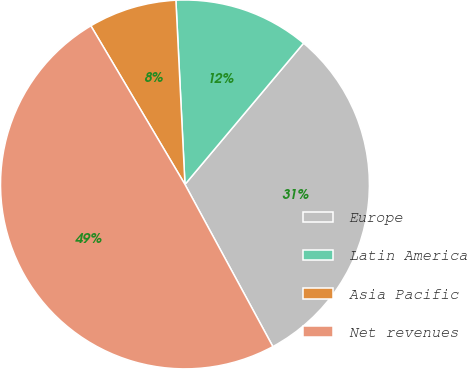Convert chart. <chart><loc_0><loc_0><loc_500><loc_500><pie_chart><fcel>Europe<fcel>Latin America<fcel>Asia Pacific<fcel>Net revenues<nl><fcel>30.98%<fcel>11.9%<fcel>7.74%<fcel>49.39%<nl></chart> 